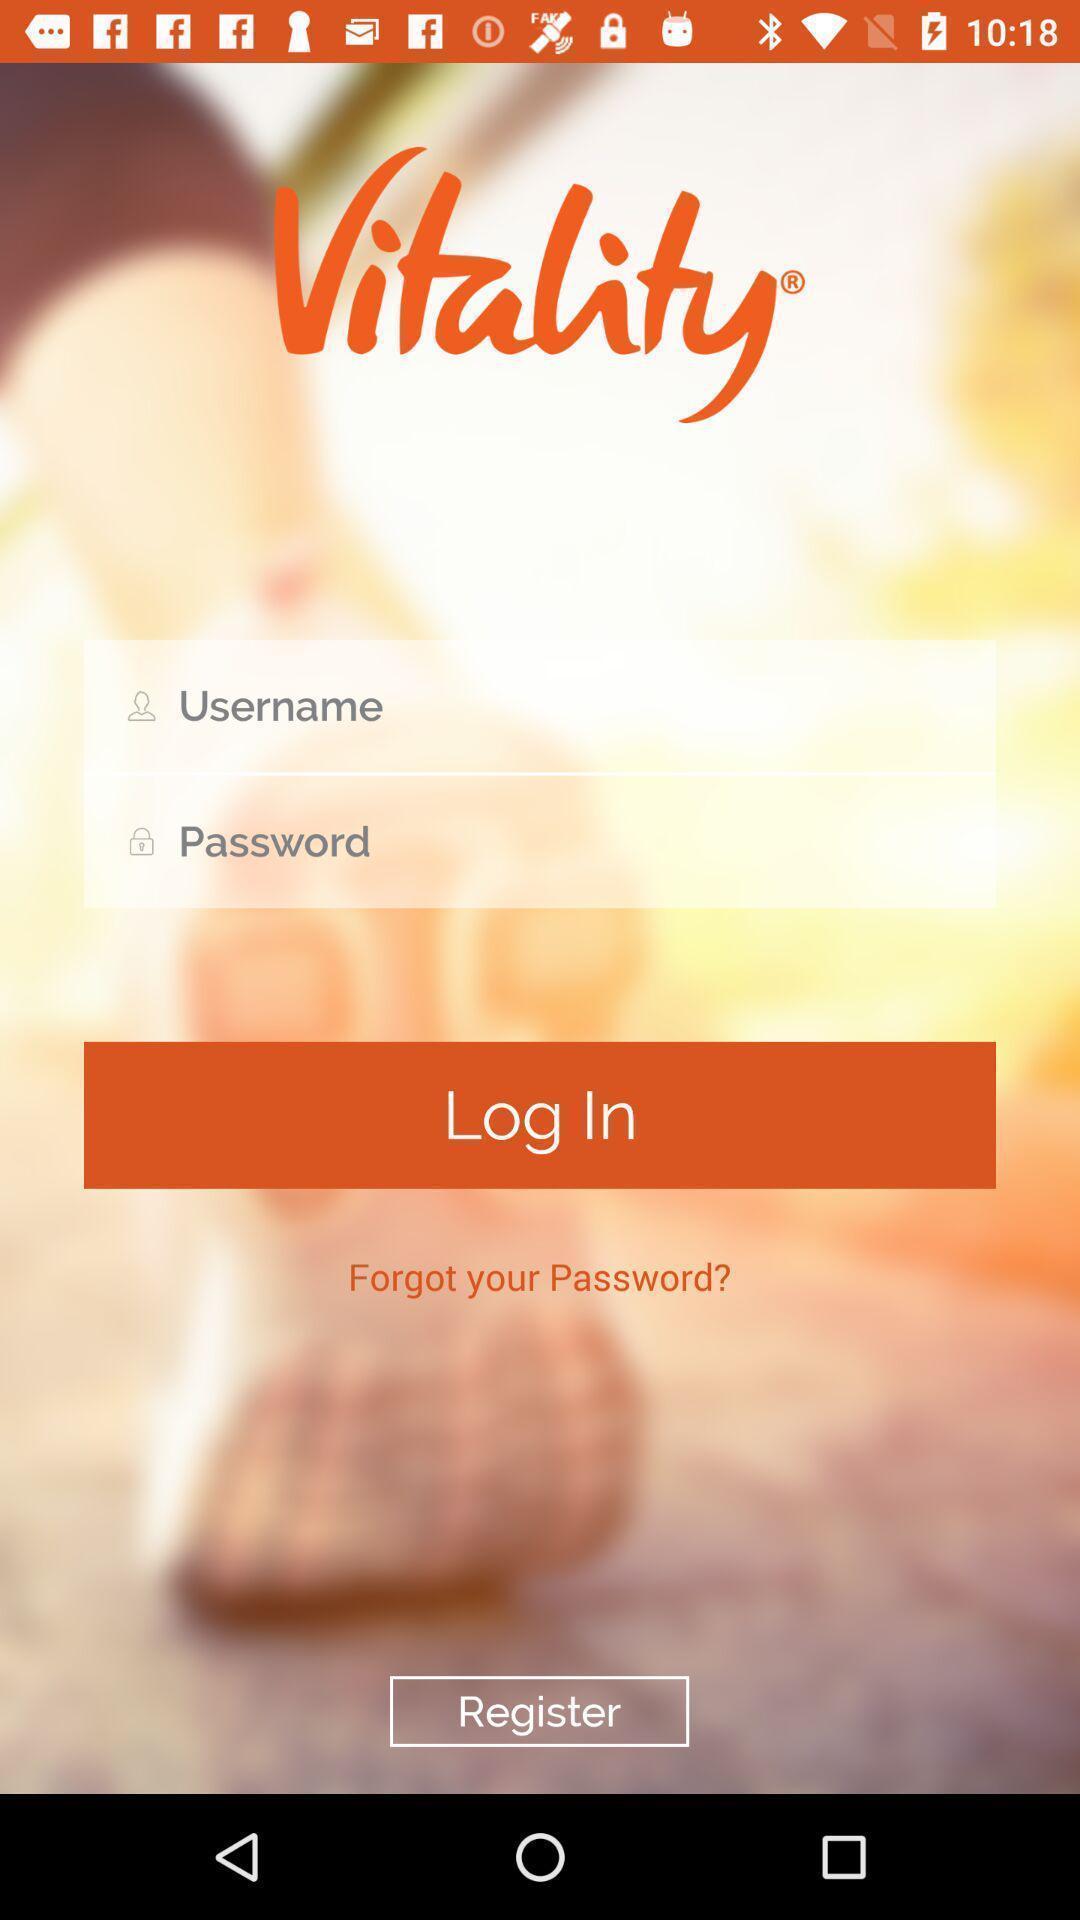Give me a summary of this screen capture. Welcome to the login page. 